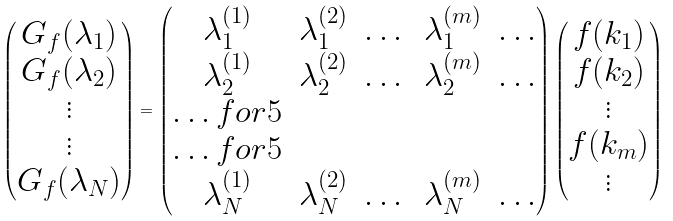Convert formula to latex. <formula><loc_0><loc_0><loc_500><loc_500>\begin{pmatrix} G _ { f } ( \lambda _ { 1 } ) \\ G _ { f } ( \lambda _ { 2 } ) \\ \vdots \\ \vdots \\ G _ { f } ( \lambda _ { N } ) \end{pmatrix} = \begin{pmatrix} \lambda _ { 1 } ^ { ( 1 ) } & \lambda _ { 1 } ^ { ( 2 ) } & \dots & \lambda _ { 1 } ^ { ( m ) } & \dots \\ \lambda _ { 2 } ^ { ( 1 ) } & \lambda _ { 2 } ^ { ( 2 ) } & \dots & \lambda _ { 2 } ^ { ( m ) } & \dots \\ \hdots f o r { 5 } \\ \hdots f o r { 5 } \\ \lambda _ { N } ^ { ( 1 ) } & \lambda _ { N } ^ { ( 2 ) } & \dots & \lambda _ { N } ^ { ( m ) } & \dots \end{pmatrix} \begin{pmatrix} f ( k _ { 1 } ) \\ f ( k _ { 2 } ) \\ \vdots \\ f ( k _ { m } ) \\ \vdots \end{pmatrix}</formula> 